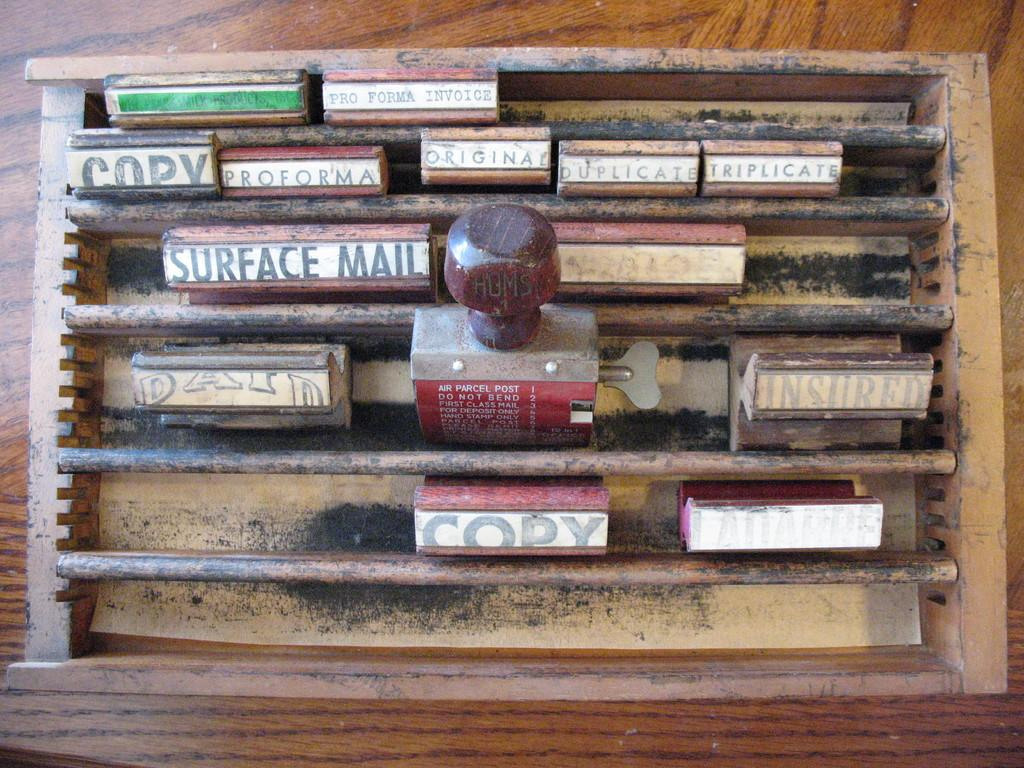What type of wall is in the center of the image? There is a wooden wall in the center of the image. What can be seen attached to the wall? There are racks in the image. What items are on the racks? There are books on the racks. What additional object is present in the image? There is a stamp in the image. How does the earthquake affect the wooden wall in the image? There is no earthquake present in the image, so its effect on the wooden wall cannot be determined. 